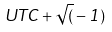<formula> <loc_0><loc_0><loc_500><loc_500>U T C + \sqrt { ( } - 1 )</formula> 